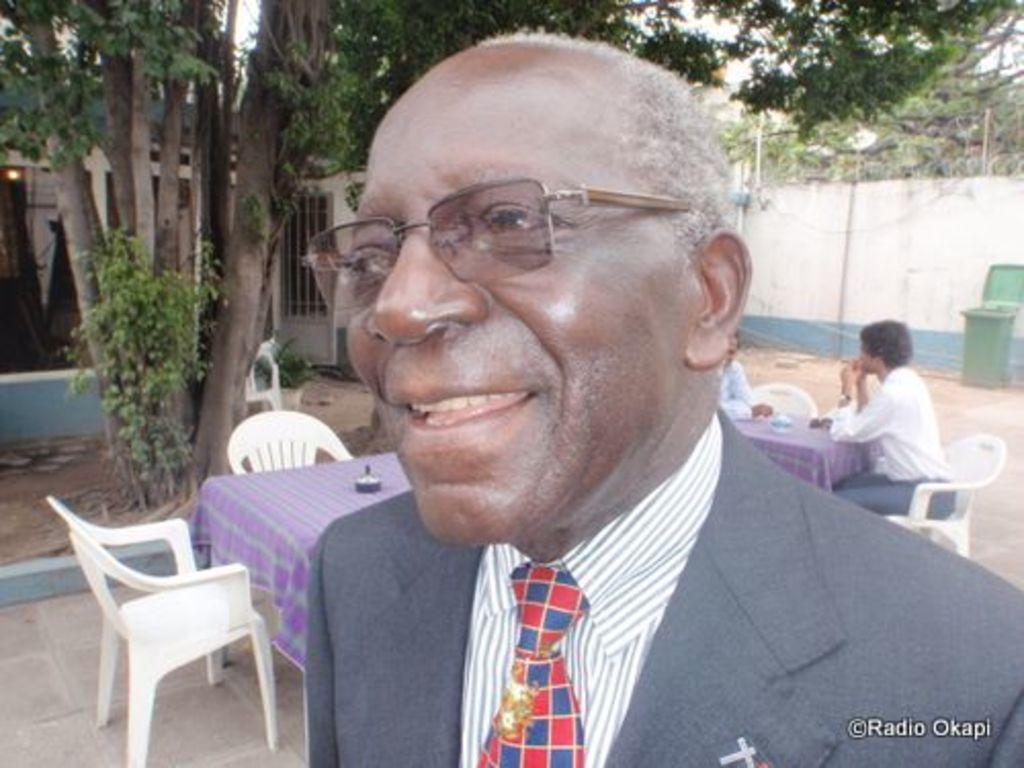Could you give a brief overview of what you see in this image? In this image, we can see tables and chairs. There are two persons on the right side of the image sitting in front of the table. There is a person at the bottom of the image wearing spectacles. There is a trash bin in front of the wall. 